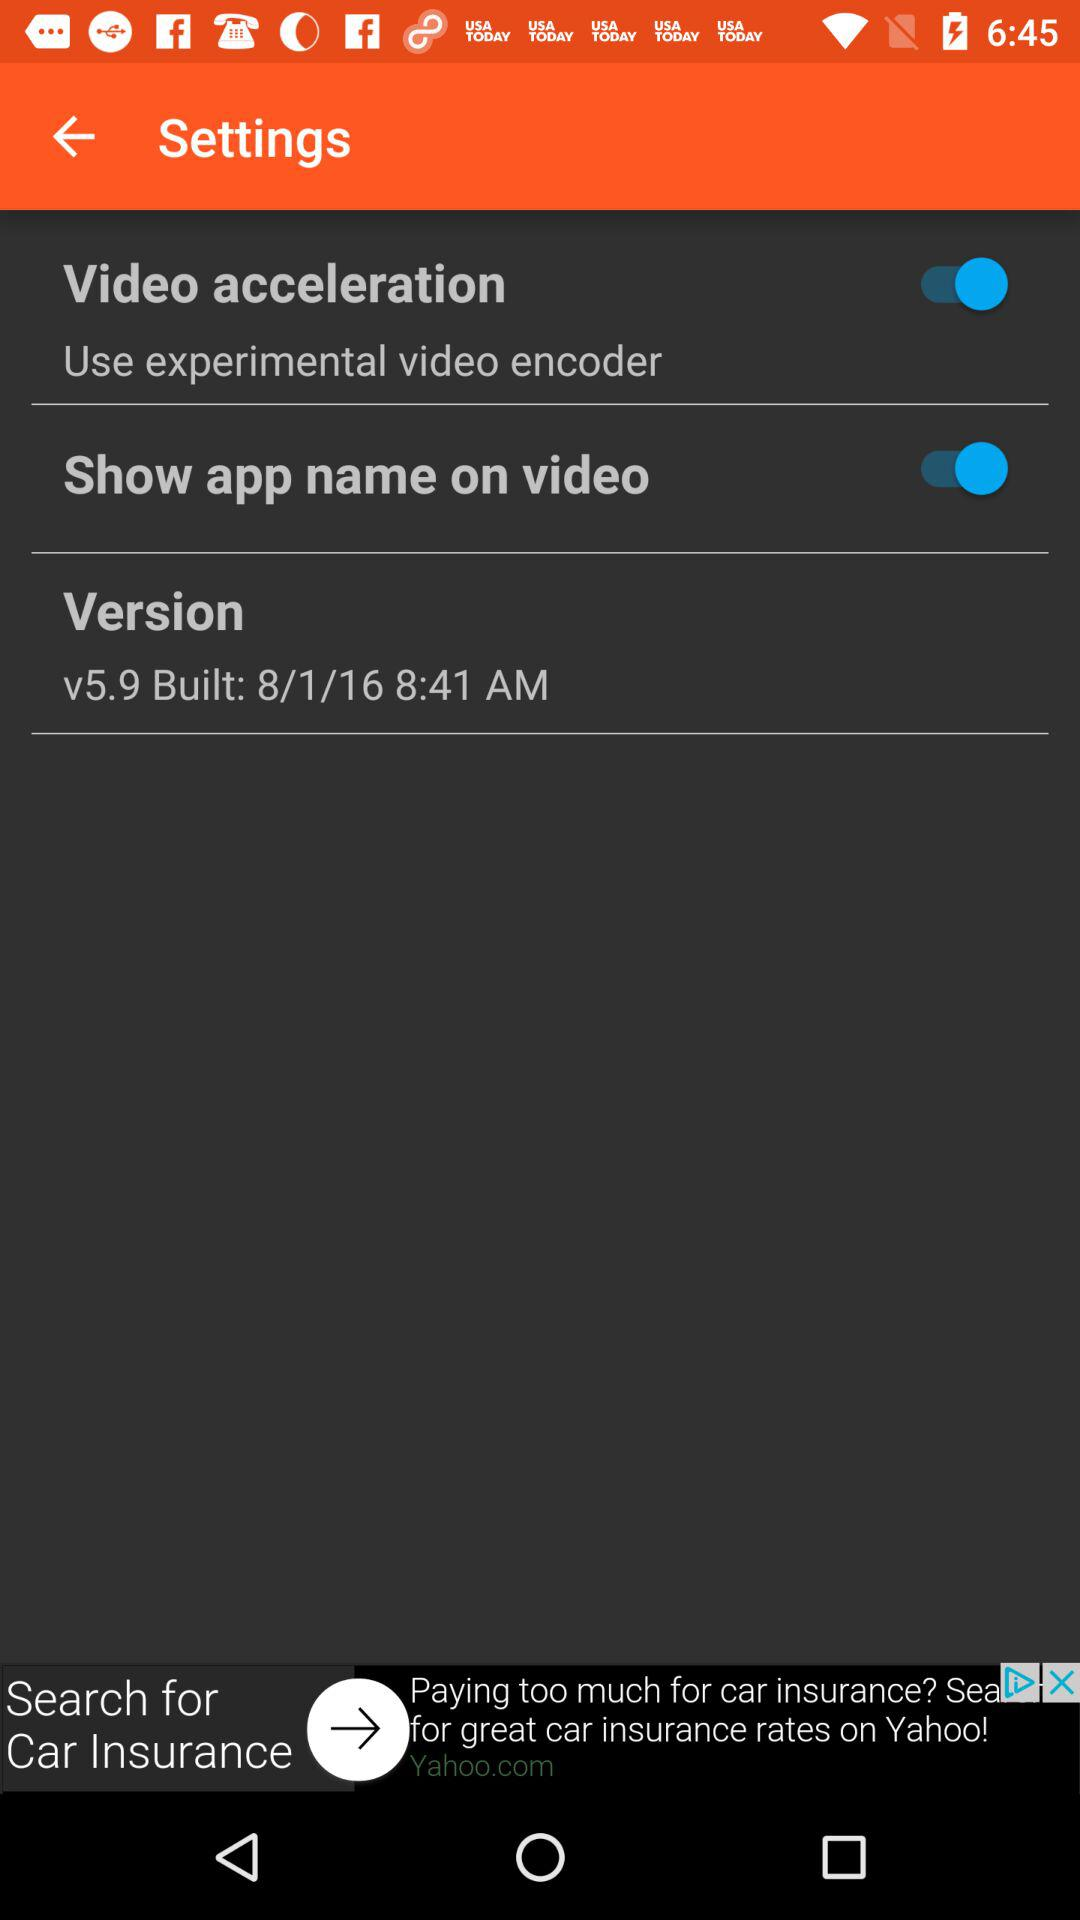What is the built date? The built date is 8/1/16. 